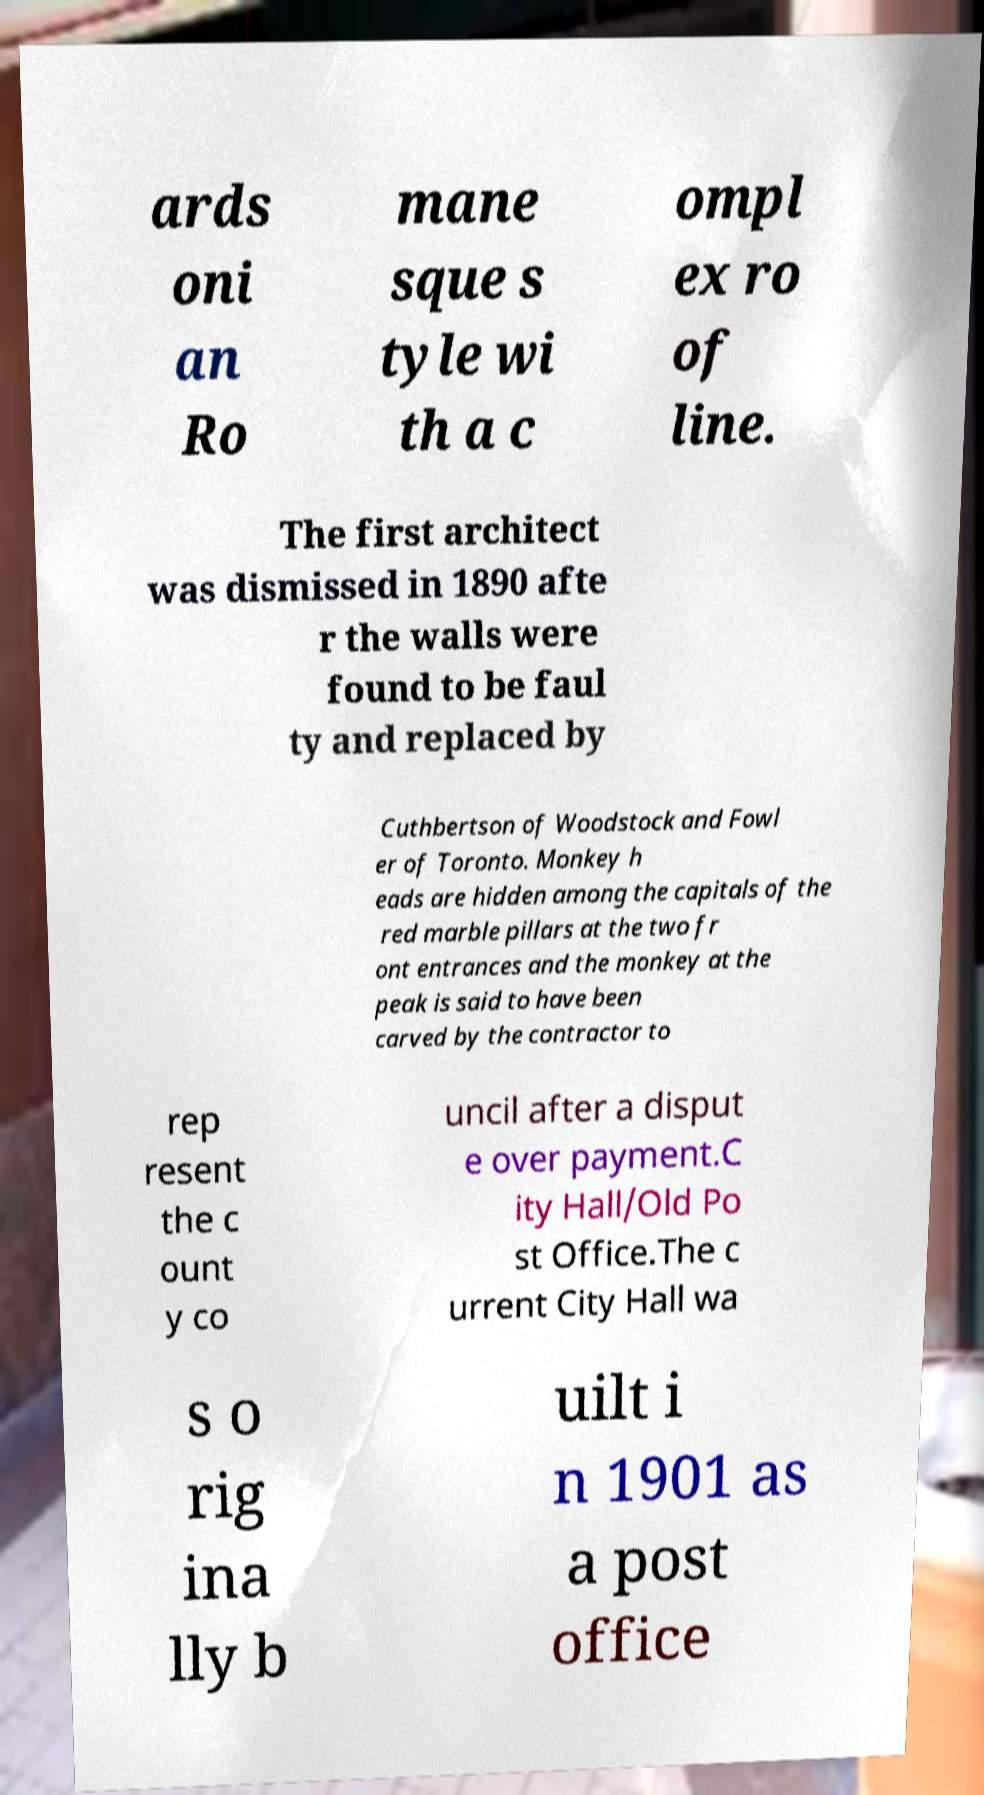Please read and relay the text visible in this image. What does it say? ards oni an Ro mane sque s tyle wi th a c ompl ex ro of line. The first architect was dismissed in 1890 afte r the walls were found to be faul ty and replaced by Cuthbertson of Woodstock and Fowl er of Toronto. Monkey h eads are hidden among the capitals of the red marble pillars at the two fr ont entrances and the monkey at the peak is said to have been carved by the contractor to rep resent the c ount y co uncil after a disput e over payment.C ity Hall/Old Po st Office.The c urrent City Hall wa s o rig ina lly b uilt i n 1901 as a post office 